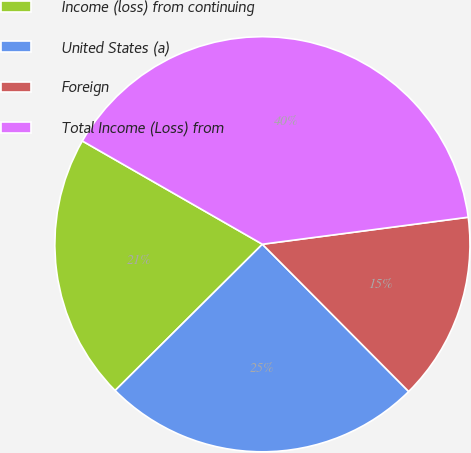<chart> <loc_0><loc_0><loc_500><loc_500><pie_chart><fcel>Income (loss) from continuing<fcel>United States (a)<fcel>Foreign<fcel>Total Income (Loss) from<nl><fcel>20.73%<fcel>25.0%<fcel>14.63%<fcel>39.63%<nl></chart> 